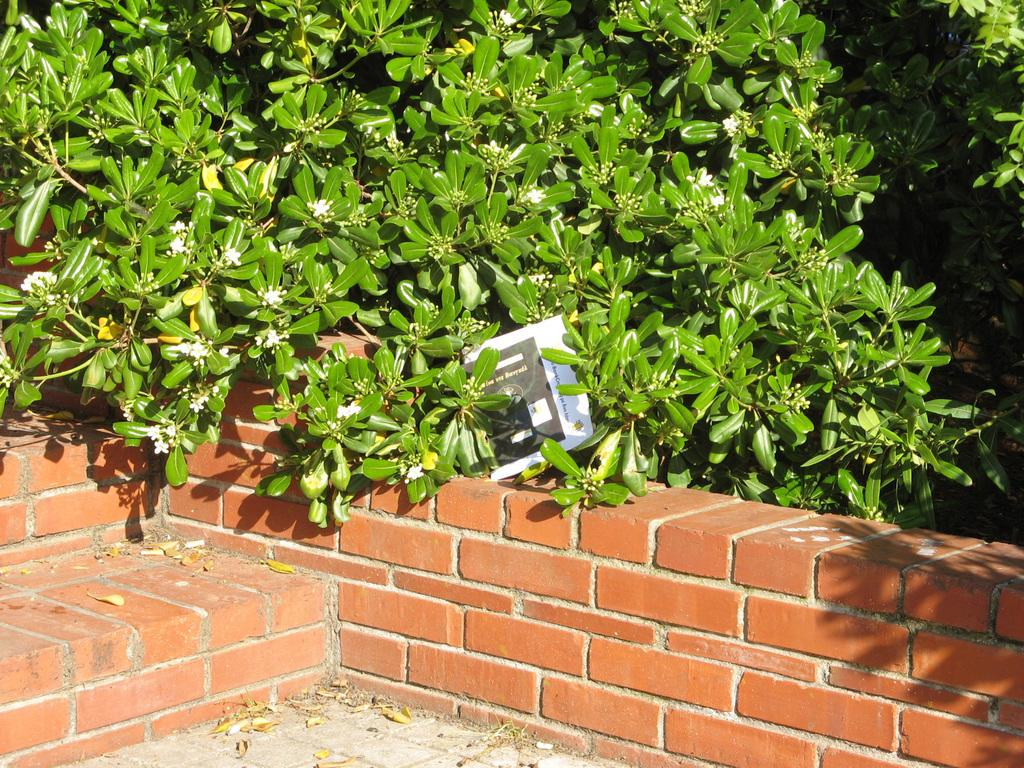What type of structure is depicted in the image? The image features a brick wall. What type of vegetation is present in the image? Green leaves are present in the image, along with flowers associated with them. What additional object can be seen in the image? A paper is visible in the image. What type of cheese is being digested by the duck in the image? There is no duck or cheese present in the image. 